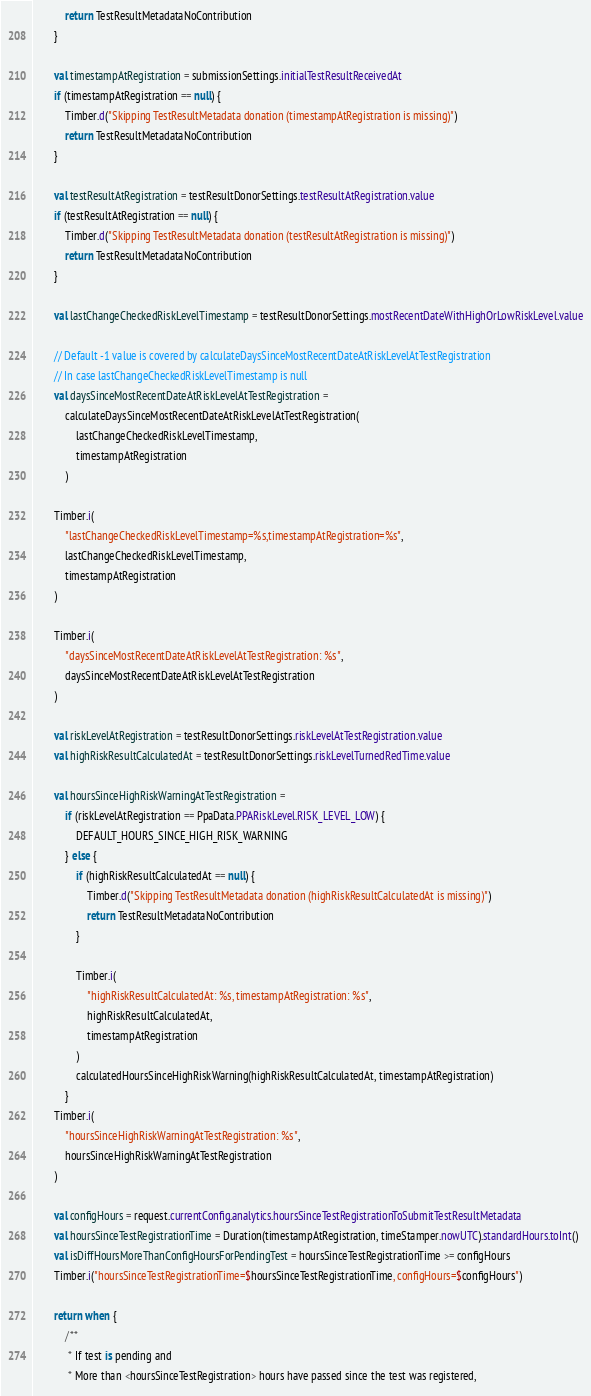Convert code to text. <code><loc_0><loc_0><loc_500><loc_500><_Kotlin_>            return TestResultMetadataNoContribution
        }

        val timestampAtRegistration = submissionSettings.initialTestResultReceivedAt
        if (timestampAtRegistration == null) {
            Timber.d("Skipping TestResultMetadata donation (timestampAtRegistration is missing)")
            return TestResultMetadataNoContribution
        }

        val testResultAtRegistration = testResultDonorSettings.testResultAtRegistration.value
        if (testResultAtRegistration == null) {
            Timber.d("Skipping TestResultMetadata donation (testResultAtRegistration is missing)")
            return TestResultMetadataNoContribution
        }

        val lastChangeCheckedRiskLevelTimestamp = testResultDonorSettings.mostRecentDateWithHighOrLowRiskLevel.value

        // Default -1 value is covered by calculateDaysSinceMostRecentDateAtRiskLevelAtTestRegistration
        // In case lastChangeCheckedRiskLevelTimestamp is null
        val daysSinceMostRecentDateAtRiskLevelAtTestRegistration =
            calculateDaysSinceMostRecentDateAtRiskLevelAtTestRegistration(
                lastChangeCheckedRiskLevelTimestamp,
                timestampAtRegistration
            )

        Timber.i(
            "lastChangeCheckedRiskLevelTimestamp=%s,timestampAtRegistration=%s",
            lastChangeCheckedRiskLevelTimestamp,
            timestampAtRegistration
        )

        Timber.i(
            "daysSinceMostRecentDateAtRiskLevelAtTestRegistration: %s",
            daysSinceMostRecentDateAtRiskLevelAtTestRegistration
        )

        val riskLevelAtRegistration = testResultDonorSettings.riskLevelAtTestRegistration.value
        val highRiskResultCalculatedAt = testResultDonorSettings.riskLevelTurnedRedTime.value

        val hoursSinceHighRiskWarningAtTestRegistration =
            if (riskLevelAtRegistration == PpaData.PPARiskLevel.RISK_LEVEL_LOW) {
                DEFAULT_HOURS_SINCE_HIGH_RISK_WARNING
            } else {
                if (highRiskResultCalculatedAt == null) {
                    Timber.d("Skipping TestResultMetadata donation (highRiskResultCalculatedAt is missing)")
                    return TestResultMetadataNoContribution
                }

                Timber.i(
                    "highRiskResultCalculatedAt: %s, timestampAtRegistration: %s",
                    highRiskResultCalculatedAt,
                    timestampAtRegistration
                )
                calculatedHoursSinceHighRiskWarning(highRiskResultCalculatedAt, timestampAtRegistration)
            }
        Timber.i(
            "hoursSinceHighRiskWarningAtTestRegistration: %s",
            hoursSinceHighRiskWarningAtTestRegistration
        )

        val configHours = request.currentConfig.analytics.hoursSinceTestRegistrationToSubmitTestResultMetadata
        val hoursSinceTestRegistrationTime = Duration(timestampAtRegistration, timeStamper.nowUTC).standardHours.toInt()
        val isDiffHoursMoreThanConfigHoursForPendingTest = hoursSinceTestRegistrationTime >= configHours
        Timber.i("hoursSinceTestRegistrationTime=$hoursSinceTestRegistrationTime, configHours=$configHours")

        return when {
            /**
             * If test is pending and
             * More than <hoursSinceTestRegistration> hours have passed since the test was registered,</code> 